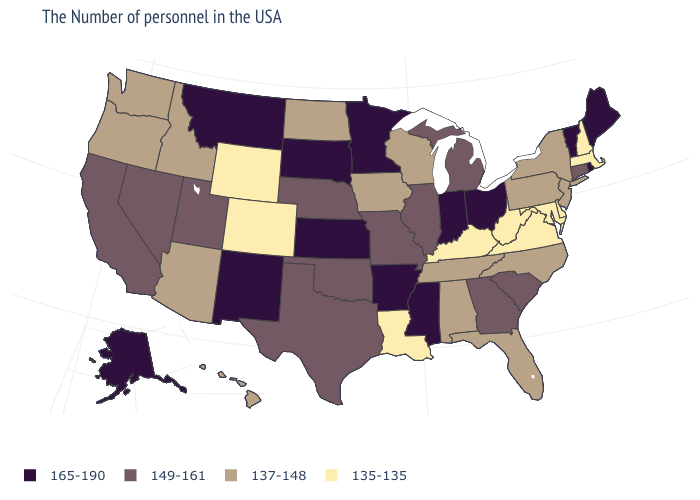Name the states that have a value in the range 165-190?
Write a very short answer. Maine, Rhode Island, Vermont, Ohio, Indiana, Mississippi, Arkansas, Minnesota, Kansas, South Dakota, New Mexico, Montana, Alaska. Which states hav the highest value in the West?
Quick response, please. New Mexico, Montana, Alaska. Does North Carolina have the highest value in the USA?
Short answer required. No. What is the value of Minnesota?
Keep it brief. 165-190. What is the value of South Dakota?
Quick response, please. 165-190. Name the states that have a value in the range 135-135?
Write a very short answer. Massachusetts, New Hampshire, Delaware, Maryland, Virginia, West Virginia, Kentucky, Louisiana, Wyoming, Colorado. Among the states that border South Dakota , does Nebraska have the highest value?
Quick response, please. No. What is the lowest value in the USA?
Give a very brief answer. 135-135. Does Colorado have the lowest value in the USA?
Concise answer only. Yes. Does Mississippi have the highest value in the South?
Keep it brief. Yes. Does Nebraska have the lowest value in the USA?
Give a very brief answer. No. Name the states that have a value in the range 149-161?
Write a very short answer. Connecticut, South Carolina, Georgia, Michigan, Illinois, Missouri, Nebraska, Oklahoma, Texas, Utah, Nevada, California. Which states hav the highest value in the West?
Write a very short answer. New Mexico, Montana, Alaska. Does Nevada have a higher value than Oregon?
Concise answer only. Yes. 